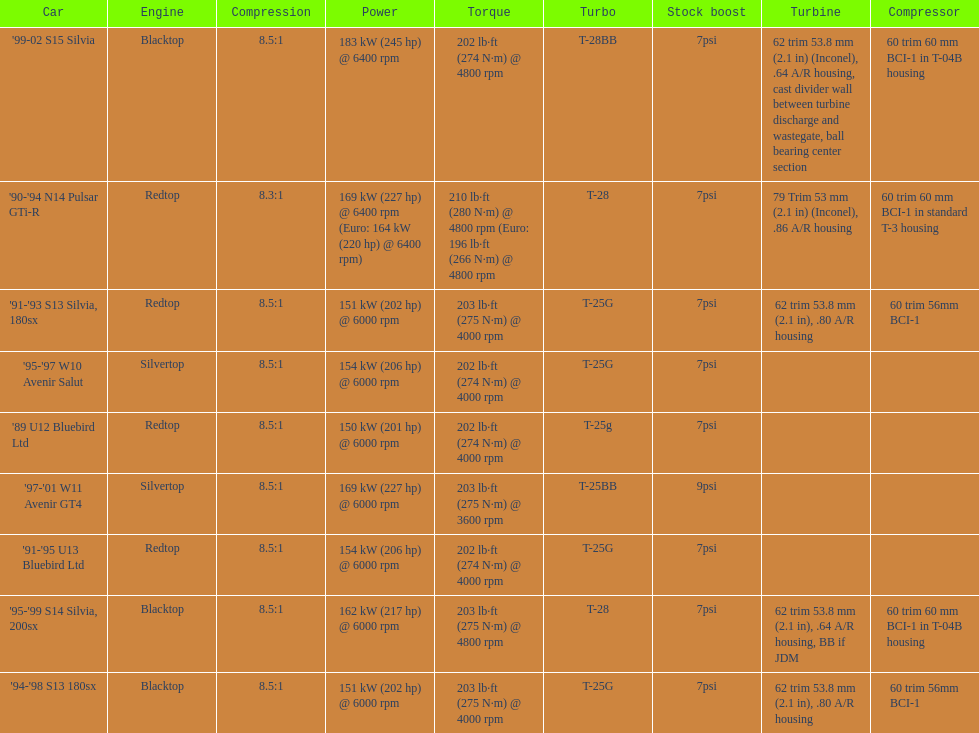Can you give me this table as a dict? {'header': ['Car', 'Engine', 'Compression', 'Power', 'Torque', 'Turbo', 'Stock boost', 'Turbine', 'Compressor'], 'rows': [["'99-02 S15 Silvia", 'Blacktop', '8.5:1', '183\xa0kW (245\xa0hp) @ 6400 rpm', '202\xa0lb·ft (274\xa0N·m) @ 4800 rpm', 'T-28BB', '7psi', '62 trim 53.8\xa0mm (2.1\xa0in) (Inconel), .64 A/R housing, cast divider wall between turbine discharge and wastegate, ball bearing center section', '60 trim 60\xa0mm BCI-1 in T-04B housing'], ["'90-'94 N14 Pulsar GTi-R", 'Redtop', '8.3:1', '169\xa0kW (227\xa0hp) @ 6400 rpm (Euro: 164\xa0kW (220\xa0hp) @ 6400 rpm)', '210\xa0lb·ft (280\xa0N·m) @ 4800 rpm (Euro: 196\xa0lb·ft (266\xa0N·m) @ 4800 rpm', 'T-28', '7psi', '79 Trim 53\xa0mm (2.1\xa0in) (Inconel), .86 A/R housing', '60 trim 60\xa0mm BCI-1 in standard T-3 housing'], ["'91-'93 S13 Silvia, 180sx", 'Redtop', '8.5:1', '151\xa0kW (202\xa0hp) @ 6000 rpm', '203\xa0lb·ft (275\xa0N·m) @ 4000 rpm', 'T-25G', '7psi', '62 trim 53.8\xa0mm (2.1\xa0in), .80 A/R housing', '60 trim 56mm BCI-1'], ["'95-'97 W10 Avenir Salut", 'Silvertop', '8.5:1', '154\xa0kW (206\xa0hp) @ 6000 rpm', '202\xa0lb·ft (274\xa0N·m) @ 4000 rpm', 'T-25G', '7psi', '', ''], ["'89 U12 Bluebird Ltd", 'Redtop', '8.5:1', '150\xa0kW (201\xa0hp) @ 6000 rpm', '202\xa0lb·ft (274\xa0N·m) @ 4000 rpm', 'T-25g', '7psi', '', ''], ["'97-'01 W11 Avenir GT4", 'Silvertop', '8.5:1', '169\xa0kW (227\xa0hp) @ 6000 rpm', '203\xa0lb·ft (275\xa0N·m) @ 3600 rpm', 'T-25BB', '9psi', '', ''], ["'91-'95 U13 Bluebird Ltd", 'Redtop', '8.5:1', '154\xa0kW (206\xa0hp) @ 6000 rpm', '202\xa0lb·ft (274\xa0N·m) @ 4000 rpm', 'T-25G', '7psi', '', ''], ["'95-'99 S14 Silvia, 200sx", 'Blacktop', '8.5:1', '162\xa0kW (217\xa0hp) @ 6000 rpm', '203\xa0lb·ft (275\xa0N·m) @ 4800 rpm', 'T-28', '7psi', '62 trim 53.8\xa0mm (2.1\xa0in), .64 A/R housing, BB if JDM', '60 trim 60\xa0mm BCI-1 in T-04B housing'], ["'94-'98 S13 180sx", 'Blacktop', '8.5:1', '151\xa0kW (202\xa0hp) @ 6000 rpm', '203\xa0lb·ft (275\xa0N·m) @ 4000 rpm', 'T-25G', '7psi', '62 trim 53.8\xa0mm (2.1\xa0in), .80 A/R housing', '60 trim 56mm BCI-1']]} Which car is the only one with more than 230 hp? '99-02 S15 Silvia. 